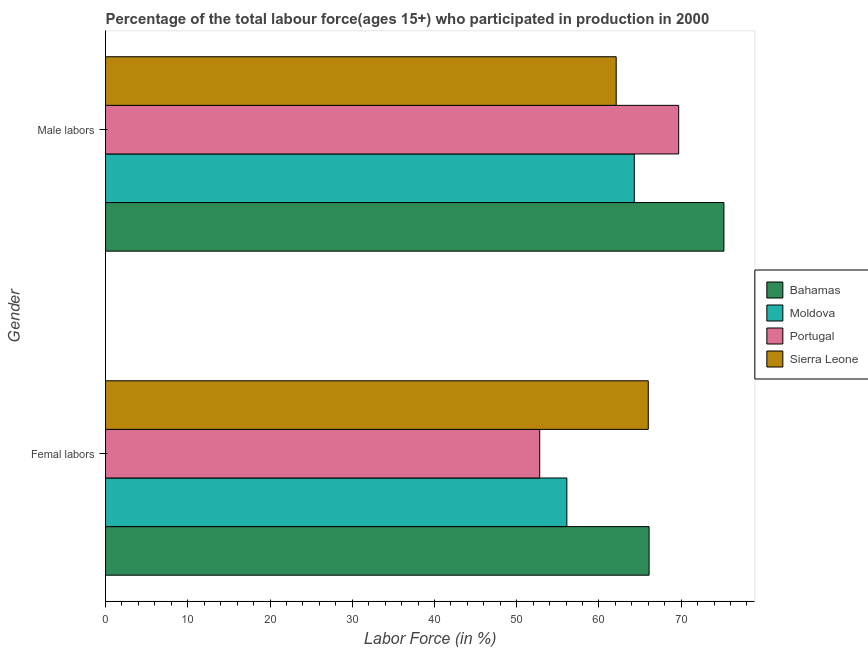How many different coloured bars are there?
Provide a succinct answer. 4. How many groups of bars are there?
Keep it short and to the point. 2. How many bars are there on the 2nd tick from the top?
Your answer should be compact. 4. How many bars are there on the 2nd tick from the bottom?
Offer a very short reply. 4. What is the label of the 1st group of bars from the top?
Provide a short and direct response. Male labors. What is the percentage of female labor force in Sierra Leone?
Provide a succinct answer. 66. Across all countries, what is the maximum percentage of female labor force?
Your answer should be very brief. 66.1. Across all countries, what is the minimum percentage of female labor force?
Ensure brevity in your answer.  52.8. In which country was the percentage of female labor force maximum?
Offer a terse response. Bahamas. In which country was the percentage of male labour force minimum?
Make the answer very short. Sierra Leone. What is the total percentage of male labour force in the graph?
Offer a terse response. 271.3. What is the difference between the percentage of female labor force in Bahamas and that in Moldova?
Ensure brevity in your answer.  10. What is the difference between the percentage of female labor force in Portugal and the percentage of male labour force in Sierra Leone?
Offer a terse response. -9.3. What is the average percentage of female labor force per country?
Offer a terse response. 60.25. What is the difference between the percentage of female labor force and percentage of male labour force in Moldova?
Offer a terse response. -8.2. In how many countries, is the percentage of female labor force greater than 38 %?
Offer a terse response. 4. What is the ratio of the percentage of male labour force in Sierra Leone to that in Bahamas?
Ensure brevity in your answer.  0.83. What does the 4th bar from the top in Femal labors represents?
Your response must be concise. Bahamas. What does the 3rd bar from the bottom in Femal labors represents?
Your answer should be compact. Portugal. How many countries are there in the graph?
Provide a succinct answer. 4. How many legend labels are there?
Offer a very short reply. 4. What is the title of the graph?
Give a very brief answer. Percentage of the total labour force(ages 15+) who participated in production in 2000. What is the label or title of the X-axis?
Give a very brief answer. Labor Force (in %). What is the label or title of the Y-axis?
Make the answer very short. Gender. What is the Labor Force (in %) in Bahamas in Femal labors?
Offer a very short reply. 66.1. What is the Labor Force (in %) in Moldova in Femal labors?
Offer a terse response. 56.1. What is the Labor Force (in %) of Portugal in Femal labors?
Give a very brief answer. 52.8. What is the Labor Force (in %) of Bahamas in Male labors?
Ensure brevity in your answer.  75.2. What is the Labor Force (in %) in Moldova in Male labors?
Provide a succinct answer. 64.3. What is the Labor Force (in %) of Portugal in Male labors?
Your response must be concise. 69.7. What is the Labor Force (in %) of Sierra Leone in Male labors?
Your answer should be compact. 62.1. Across all Gender, what is the maximum Labor Force (in %) in Bahamas?
Ensure brevity in your answer.  75.2. Across all Gender, what is the maximum Labor Force (in %) in Moldova?
Your response must be concise. 64.3. Across all Gender, what is the maximum Labor Force (in %) in Portugal?
Give a very brief answer. 69.7. Across all Gender, what is the minimum Labor Force (in %) in Bahamas?
Your response must be concise. 66.1. Across all Gender, what is the minimum Labor Force (in %) of Moldova?
Give a very brief answer. 56.1. Across all Gender, what is the minimum Labor Force (in %) in Portugal?
Offer a terse response. 52.8. Across all Gender, what is the minimum Labor Force (in %) of Sierra Leone?
Give a very brief answer. 62.1. What is the total Labor Force (in %) of Bahamas in the graph?
Give a very brief answer. 141.3. What is the total Labor Force (in %) of Moldova in the graph?
Provide a succinct answer. 120.4. What is the total Labor Force (in %) of Portugal in the graph?
Your response must be concise. 122.5. What is the total Labor Force (in %) in Sierra Leone in the graph?
Your response must be concise. 128.1. What is the difference between the Labor Force (in %) of Bahamas in Femal labors and that in Male labors?
Give a very brief answer. -9.1. What is the difference between the Labor Force (in %) in Moldova in Femal labors and that in Male labors?
Make the answer very short. -8.2. What is the difference between the Labor Force (in %) in Portugal in Femal labors and that in Male labors?
Provide a short and direct response. -16.9. What is the difference between the Labor Force (in %) in Sierra Leone in Femal labors and that in Male labors?
Your response must be concise. 3.9. What is the average Labor Force (in %) in Bahamas per Gender?
Make the answer very short. 70.65. What is the average Labor Force (in %) in Moldova per Gender?
Offer a very short reply. 60.2. What is the average Labor Force (in %) in Portugal per Gender?
Provide a succinct answer. 61.25. What is the average Labor Force (in %) in Sierra Leone per Gender?
Provide a succinct answer. 64.05. What is the difference between the Labor Force (in %) in Bahamas and Labor Force (in %) in Moldova in Femal labors?
Ensure brevity in your answer.  10. What is the difference between the Labor Force (in %) in Bahamas and Labor Force (in %) in Portugal in Femal labors?
Your response must be concise. 13.3. What is the difference between the Labor Force (in %) of Portugal and Labor Force (in %) of Sierra Leone in Femal labors?
Offer a terse response. -13.2. What is the difference between the Labor Force (in %) in Bahamas and Labor Force (in %) in Portugal in Male labors?
Give a very brief answer. 5.5. What is the difference between the Labor Force (in %) in Bahamas and Labor Force (in %) in Sierra Leone in Male labors?
Your answer should be compact. 13.1. What is the difference between the Labor Force (in %) of Moldova and Labor Force (in %) of Portugal in Male labors?
Offer a very short reply. -5.4. What is the difference between the Labor Force (in %) in Portugal and Labor Force (in %) in Sierra Leone in Male labors?
Provide a short and direct response. 7.6. What is the ratio of the Labor Force (in %) in Bahamas in Femal labors to that in Male labors?
Keep it short and to the point. 0.88. What is the ratio of the Labor Force (in %) in Moldova in Femal labors to that in Male labors?
Ensure brevity in your answer.  0.87. What is the ratio of the Labor Force (in %) in Portugal in Femal labors to that in Male labors?
Ensure brevity in your answer.  0.76. What is the ratio of the Labor Force (in %) of Sierra Leone in Femal labors to that in Male labors?
Ensure brevity in your answer.  1.06. What is the difference between the highest and the second highest Labor Force (in %) of Bahamas?
Make the answer very short. 9.1. What is the difference between the highest and the lowest Labor Force (in %) of Portugal?
Your answer should be very brief. 16.9. What is the difference between the highest and the lowest Labor Force (in %) in Sierra Leone?
Provide a succinct answer. 3.9. 